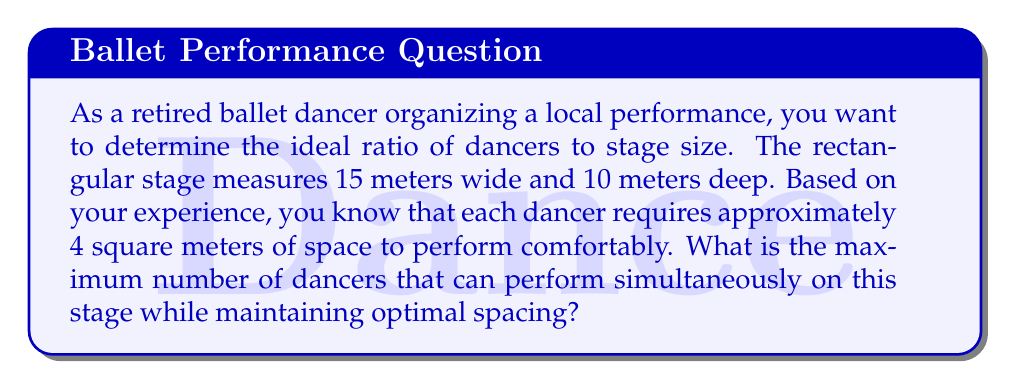Help me with this question. To solve this problem, we need to follow these steps:

1. Calculate the total area of the stage:
   $$A_{stage} = \text{width} \times \text{depth}$$
   $$A_{stage} = 15 \text{ m} \times 10 \text{ m} = 150 \text{ m}^2$$

2. Determine the area required per dancer:
   $$A_{dancer} = 4 \text{ m}^2$$

3. Calculate the maximum number of dancers by dividing the stage area by the area per dancer:
   $$\text{Max dancers} = \frac{A_{stage}}{A_{dancer}}$$
   $$\text{Max dancers} = \frac{150 \text{ m}^2}{4 \text{ m}^2} = 37.5$$

4. Since we can't have a fractional number of dancers, we need to round down to the nearest whole number:
   $$\text{Max dancers} = \lfloor 37.5 \rfloor = 37$$

Therefore, the maximum number of dancers that can perform simultaneously on this stage while maintaining optimal spacing is 37.
Answer: 37 dancers 